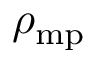<formula> <loc_0><loc_0><loc_500><loc_500>\rho _ { m p }</formula> 